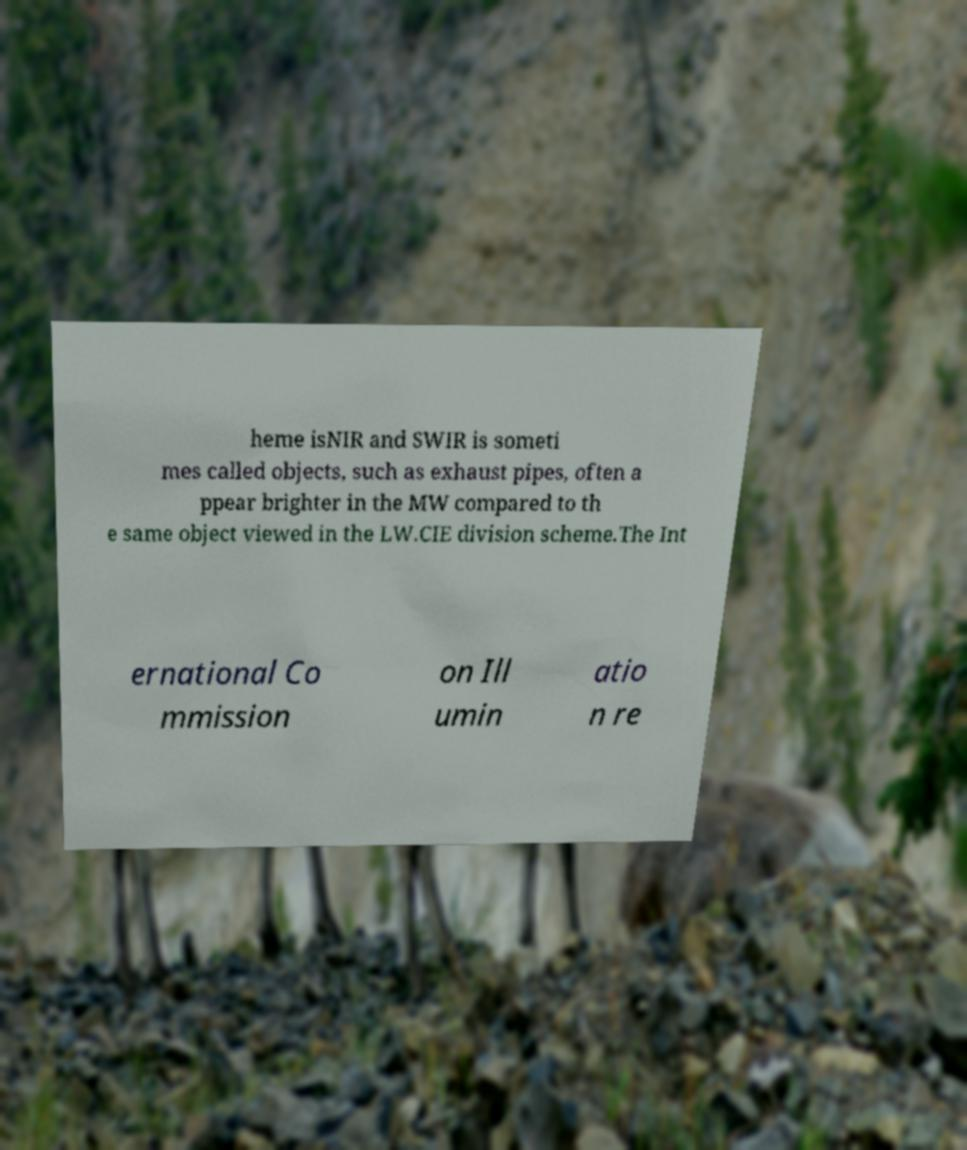I need the written content from this picture converted into text. Can you do that? heme isNIR and SWIR is someti mes called objects, such as exhaust pipes, often a ppear brighter in the MW compared to th e same object viewed in the LW.CIE division scheme.The Int ernational Co mmission on Ill umin atio n re 